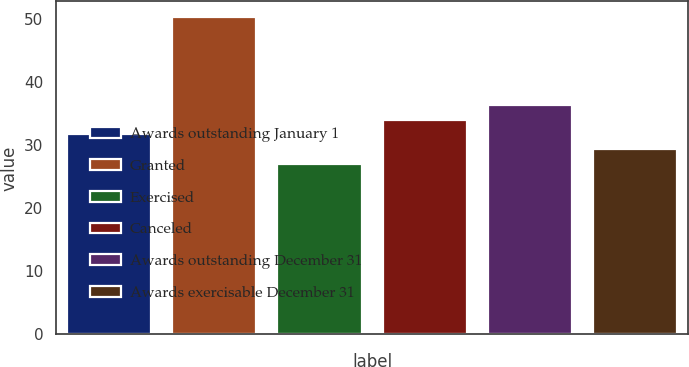Convert chart. <chart><loc_0><loc_0><loc_500><loc_500><bar_chart><fcel>Awards outstanding January 1<fcel>Granted<fcel>Exercised<fcel>Canceled<fcel>Awards outstanding December 31<fcel>Awards exercisable December 31<nl><fcel>31.65<fcel>50.23<fcel>27.01<fcel>33.97<fcel>36.29<fcel>29.33<nl></chart> 